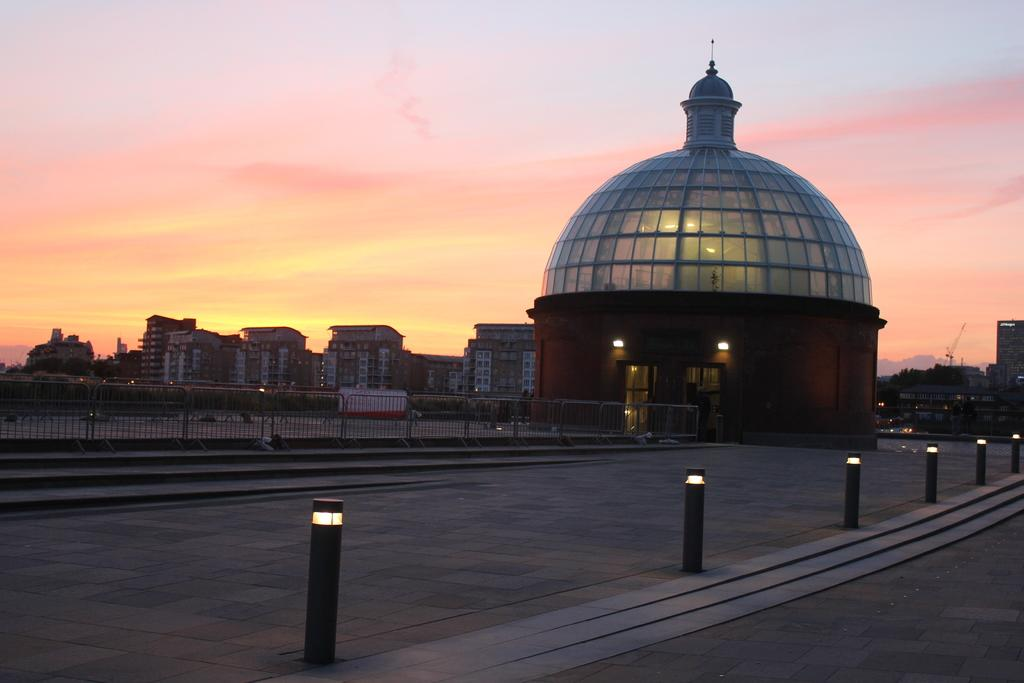What can be seen attached to small poles on the road in the image? There are lights attached to small poles on the road in the image. What is visible in the background of the image? There is a fence and buildings in the background of the image. What can be seen in the sky in the image? There are clouds in the sky in the image. How many feet are visible in the image? There are no feet visible in the image. Can you tell me which building in the image is offering help? There is no indication of any building offering help in the image. 